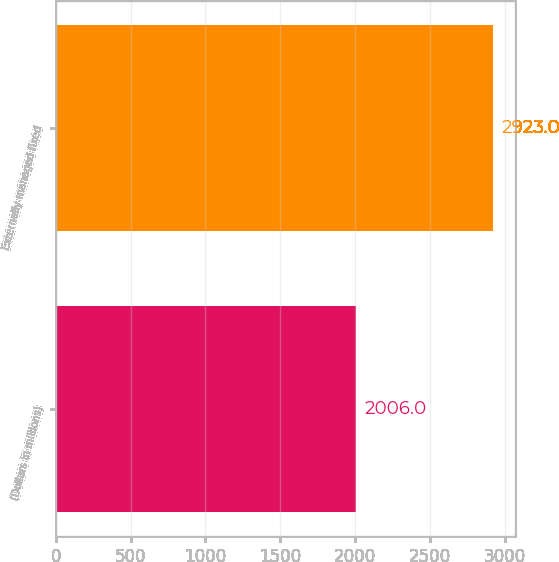Convert chart to OTSL. <chart><loc_0><loc_0><loc_500><loc_500><bar_chart><fcel>(Dollars in millions)<fcel>Externally managed fixed<nl><fcel>2006<fcel>2923<nl></chart> 